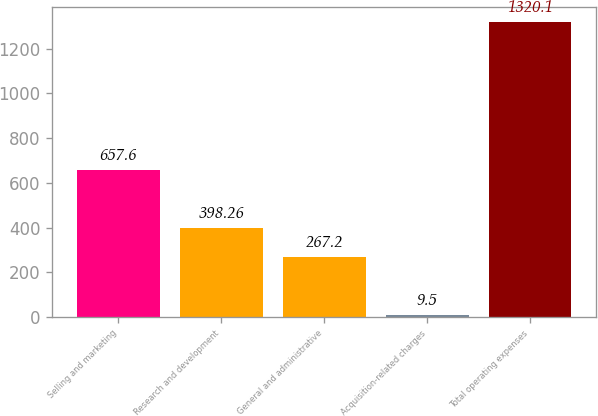Convert chart. <chart><loc_0><loc_0><loc_500><loc_500><bar_chart><fcel>Selling and marketing<fcel>Research and development<fcel>General and administrative<fcel>Acquisition-related charges<fcel>Total operating expenses<nl><fcel>657.6<fcel>398.26<fcel>267.2<fcel>9.5<fcel>1320.1<nl></chart> 